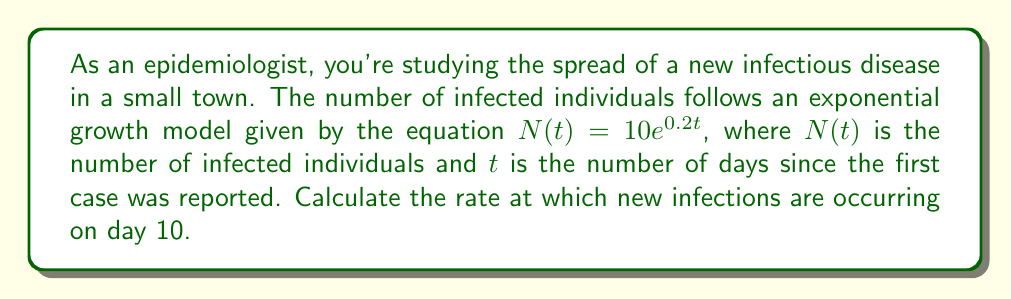Provide a solution to this math problem. To solve this problem, we need to follow these steps:

1) The rate of new infections at any given time is represented by the derivative of the function $N(t)$. 

2) Let's find the derivative of $N(t) = 10e^{0.2t}$:
   $$\frac{d}{dt}N(t) = 10 \cdot 0.2 \cdot e^{0.2t} = 2e^{0.2t}$$

3) This derivative $\frac{d}{dt}N(t)$ gives us the rate of new infections at any time $t$.

4) To find the rate on day 10, we need to substitute $t=10$ into this expression:
   $$\frac{d}{dt}N(10) = 2e^{0.2 \cdot 10} = 2e^2$$

5) Calculate this value:
   $$2e^2 \approx 2 \cdot 7.389 \approx 14.778$$

6) Round to the nearest whole number, as we're dealing with people:
   $$14.778 \approx 15$$

Therefore, on day 10, new infections are occurring at a rate of approximately 15 people per day.
Answer: 15 new infections per day 